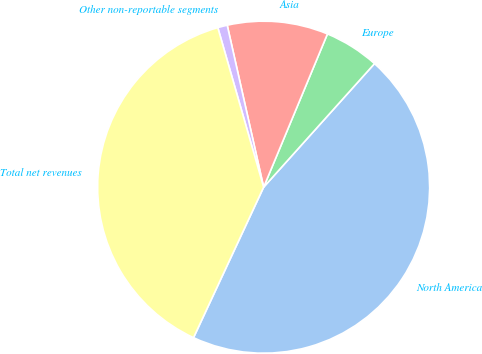Convert chart. <chart><loc_0><loc_0><loc_500><loc_500><pie_chart><fcel>North America<fcel>Europe<fcel>Asia<fcel>Other non-reportable segments<fcel>Total net revenues<nl><fcel>45.3%<fcel>5.36%<fcel>9.8%<fcel>0.93%<fcel>38.61%<nl></chart> 